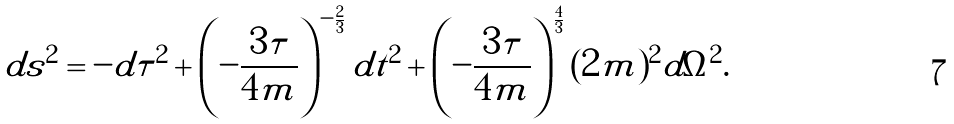<formula> <loc_0><loc_0><loc_500><loc_500>d s ^ { 2 } = - d \tau ^ { 2 } + \left ( - \frac { 3 \tau } { 4 m } \right ) ^ { - \frac { 2 } { 3 } } d t ^ { 2 } + \left ( - \frac { 3 \tau } { 4 m } \right ) ^ { \frac { 4 } { 3 } } ( 2 m ) ^ { 2 } d \Omega ^ { 2 } .</formula> 